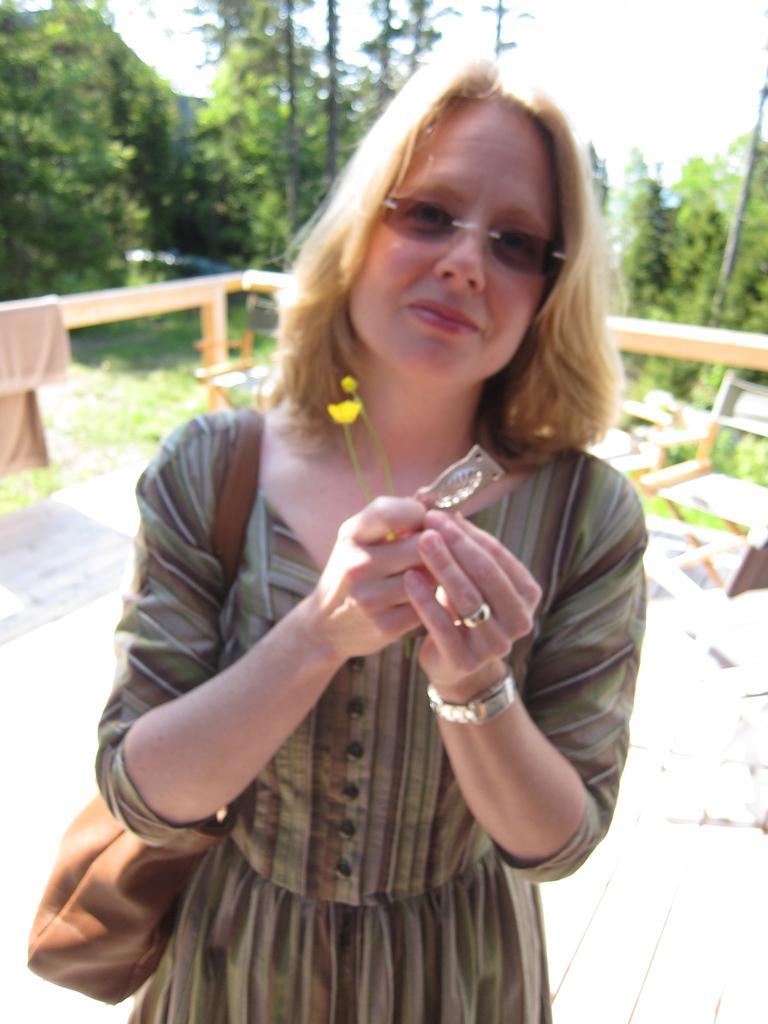Could you give a brief overview of what you see in this image? In this picture we can see a woman wearing a bag and holding an object in her hand. There is a cloth on a wooden object. We can see a few trees in the background. 